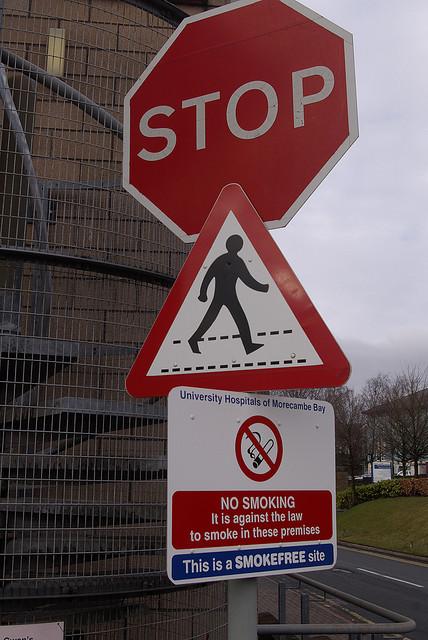What does the bottom sign say?
Write a very short answer. This is smoke free site. What hand is this?
Write a very short answer. Left. What body part is depicted in the sign?
Write a very short answer. Body. Is this a rare stop sign?
Keep it brief. No. What type of fence is this?
Short answer required. Metal. How many street signs are on the poll?
Keep it brief. 3. Is the sign upside down?
Concise answer only. No. What color is the word "stop"?
Give a very brief answer. White. Is the stop sign sitting on the side of a road?
Concise answer only. Yes. What does the lower portion of the sign say?
Concise answer only. No smoking. Overcast or sunny?
Give a very brief answer. Overcast. Has the sign been vandalized?
Keep it brief. No. What does the small sign under the stop sign say?
Short answer required. No smoking. Where the stop sign is fitted?
Write a very short answer. On top. What type of stick was used to make this sign?
Be succinct. Metal. How many signs are there?
Quick response, please. 3. What is on the sign?
Be succinct. Stop. What languages are on the blue and white sign?
Short answer required. English. Does the road split off into two  roads?
Concise answer only. No. Is this a crosswalk?
Write a very short answer. Yes. Does the sign have graffiti on it?
Quick response, please. No. What is the fine for violators according to the sign?
Keep it brief. 0. Can you smoke here?
Quick response, please. No. What is in the reflection of the stop sign?
Concise answer only. Nothing. Is this the desert?
Be succinct. No. What language is the sign in?
Keep it brief. English. How many stickers are on the stop sign?
Quick response, please. 0. What is next to the building?
Be succinct. Stop sign. Who is the man pictured on the sign?
Concise answer only. Pedestrian. Are the three signs pointing right or left?
Short answer required. Right. Was this taken in America?
Give a very brief answer. Yes. What language is this?
Be succinct. English. What colors are the sign?
Give a very brief answer. Red and white. Is there graffiti on the sign?
Concise answer only. No. What does the triangle sign advice?
Give a very brief answer. Walk. IS there graffiti on this sign?
Be succinct. No. Who is on the picture?
Keep it brief. Street signs. What object is on the sign?
Write a very short answer. Person. What does it say on the sign?
Quick response, please. Stop. What condition is the stop sign in?
Keep it brief. Good. 